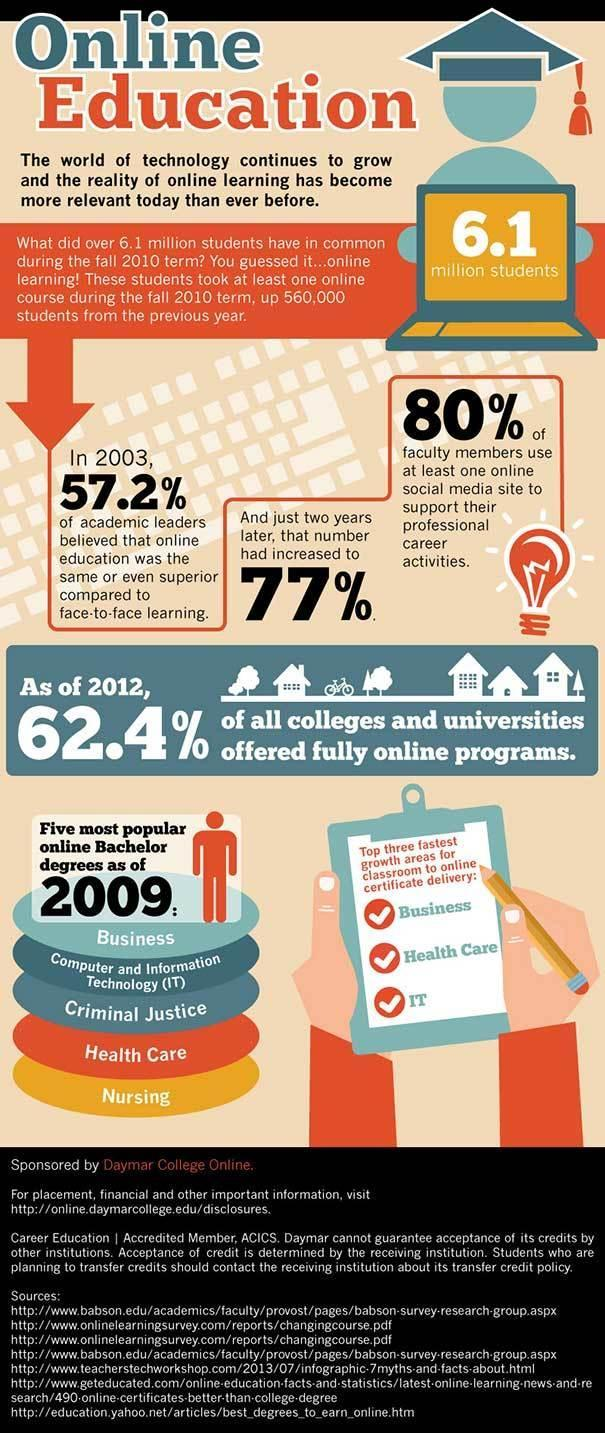WHat are the top 3 fasted growth areas for classroom to online certificate delivery
Answer the question with a short phrase. Business, Health Care, IT How many students took online courses  in 2009 60440000 How many more % of academic leaders in 2005 found online education same or even superior to face-to-face learning when compared to 2003 19.8 What is the colour of the computer screen, yellow or red yellow Other than IT and Health  Care which are the other popular online Bachelor degree in 2009 Business, Criminal Justice, Nursing 